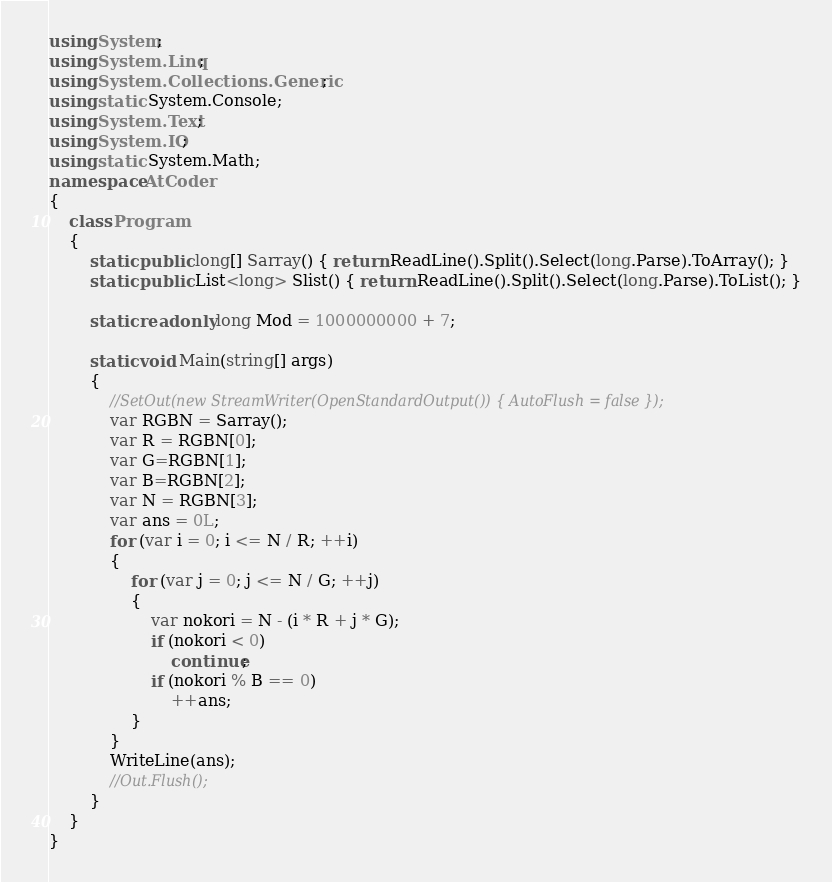Convert code to text. <code><loc_0><loc_0><loc_500><loc_500><_C#_>using System;
using System.Linq;
using System.Collections.Generic;
using static System.Console;
using System.Text;
using System.IO;
using static System.Math;
namespace AtCoder
{
    class Program
    {
        static public long[] Sarray() { return ReadLine().Split().Select(long.Parse).ToArray(); }
        static public List<long> Slist() { return ReadLine().Split().Select(long.Parse).ToList(); }

        static readonly long Mod = 1000000000 + 7;

        static void Main(string[] args)
        {
            //SetOut(new StreamWriter(OpenStandardOutput()) { AutoFlush = false });
            var RGBN = Sarray();
            var R = RGBN[0];
            var G=RGBN[1];
            var B=RGBN[2];
            var N = RGBN[3];
            var ans = 0L;
            for (var i = 0; i <= N / R; ++i)
            {
                for (var j = 0; j <= N / G; ++j)
                {
                    var nokori = N - (i * R + j * G);
                    if (nokori < 0)
                        continue;
                    if (nokori % B == 0)
                        ++ans;
                }
            }
            WriteLine(ans);
            //Out.Flush();
        }
    }
}</code> 